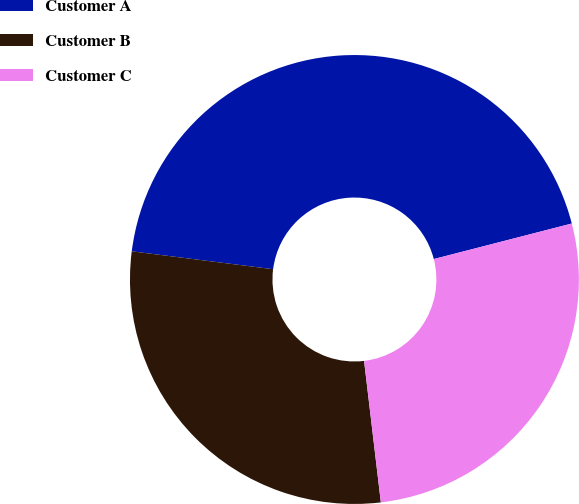Convert chart to OTSL. <chart><loc_0><loc_0><loc_500><loc_500><pie_chart><fcel>Customer A<fcel>Customer B<fcel>Customer C<nl><fcel>43.98%<fcel>28.88%<fcel>27.13%<nl></chart> 